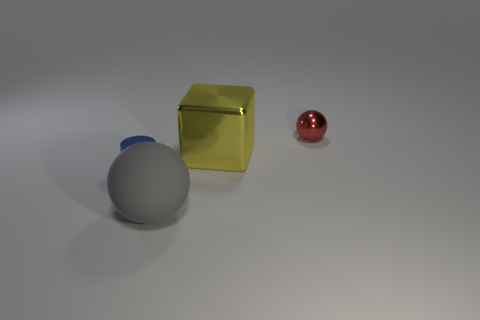Does the lighting in the scene suggest a particular time of day? The lighting in the scene is muted and diffused, without strong shadows or highlights, which makes it difficult to determine a specific time of day. It appears to be a controlled indoor lighting environment rather than natural sunlight. Is there any indication of where this scenario could be taking place? There are no definitive indicators of location in this image. The uniform background and lack of contextual objects suggest it could be a staged setup within a studio, designed to highlight the objects without external distractions. 